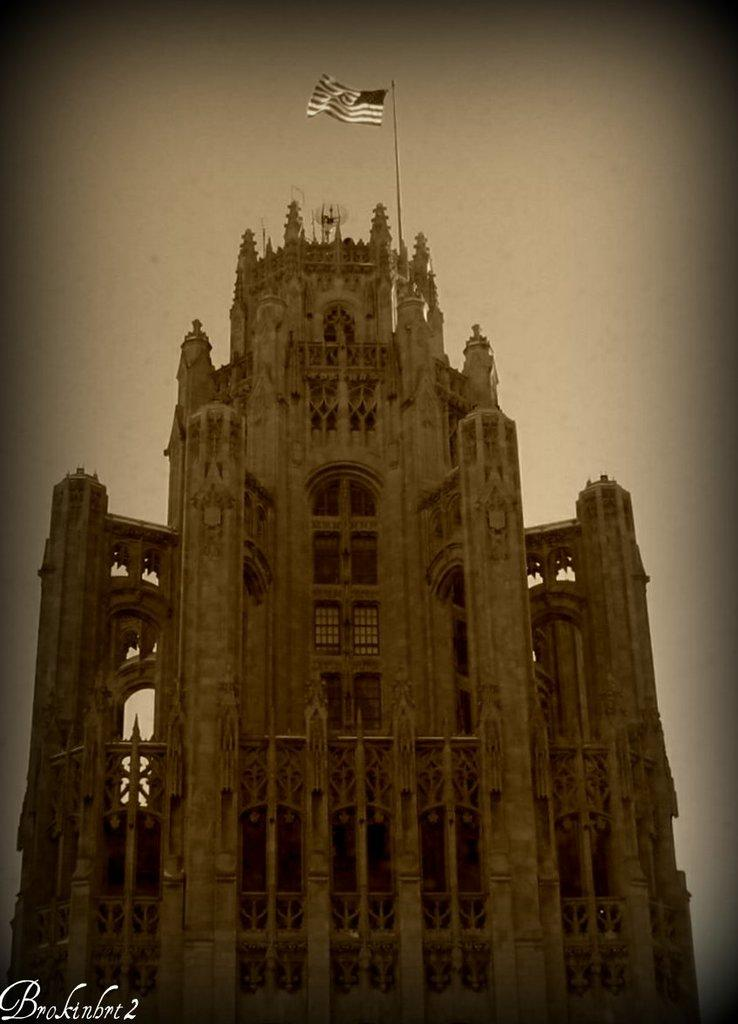What is the main subject of the picture? The main subject of the picture is a monument. What is on top of the monument? There is a flag on top of the monument. What can be seen at the top of the picture? The sky is visible at the top of the picture. Can you describe any additional features in the picture? There is a watermark in the bottom left corner of the picture. What type of idea can be seen growing in the bucket next to the monument? There is no bucket or idea present in the image; it features a monument with a flag and a watermark in the corner. 